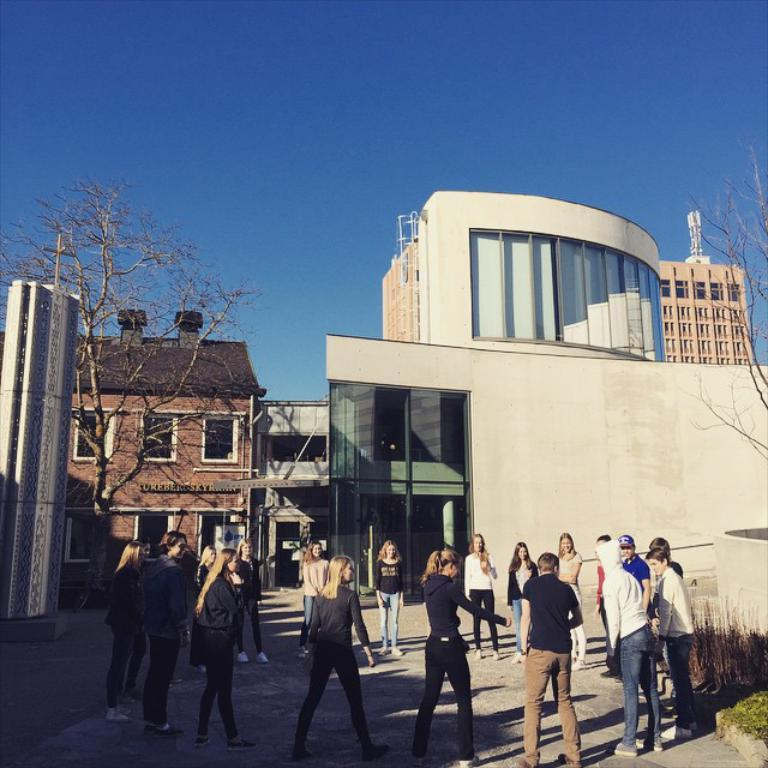What are the people in the image doing? The people in the image are standing and forming a circle. What can be seen in the background of the image? There are buildings and trees in the background of the image. Is the queen present in the image? There is no queen present in the image. What is the noise level in the image? The noise level cannot be determined from the image, as it is a visual medium. 